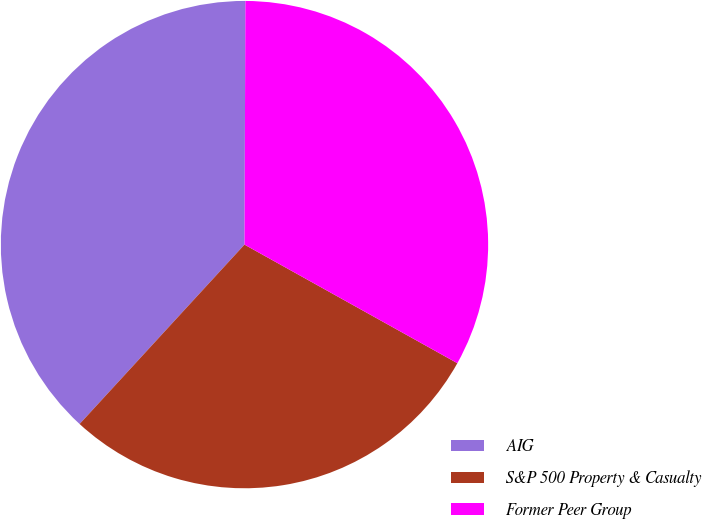Convert chart to OTSL. <chart><loc_0><loc_0><loc_500><loc_500><pie_chart><fcel>AIG<fcel>S&P 500 Property & Casualty<fcel>Former Peer Group<nl><fcel>38.23%<fcel>28.74%<fcel>33.03%<nl></chart> 